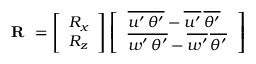Convert formula to latex. <formula><loc_0><loc_0><loc_500><loc_500>R = \left [ \begin{array} { l } { R _ { x } } \\ { R _ { z } } \end{array} \right ] \left [ \begin{array} { l } { \, \overline { { { u ^ { \prime } \, \theta ^ { \prime } } } } - \overline { { { u ^ { \prime } } } } \, \overline { { { \theta ^ { \prime } } } } \, } \\ { \, \overline { { { w ^ { \prime } \, \theta ^ { \prime } } } } - \overline { { { w ^ { \prime } } } } \, \overline { { { \theta ^ { \prime } } } } \, } \end{array} \right ]</formula> 